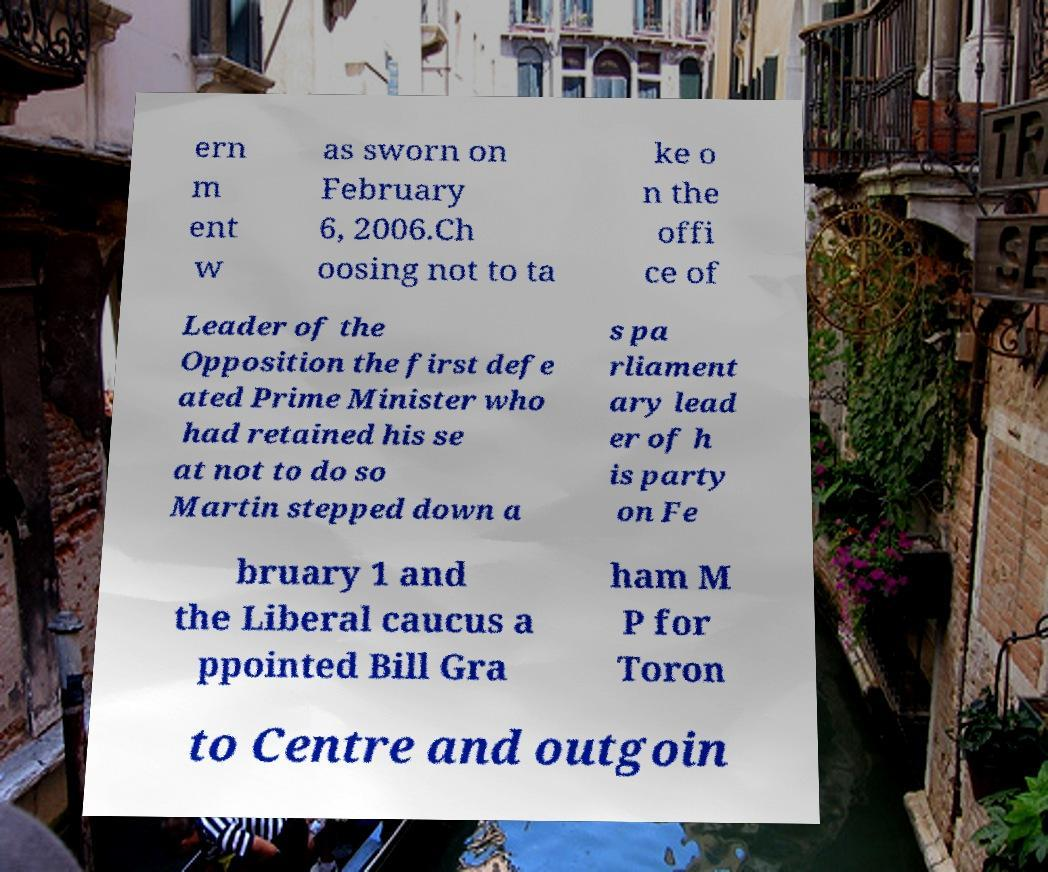There's text embedded in this image that I need extracted. Can you transcribe it verbatim? ern m ent w as sworn on February 6, 2006.Ch oosing not to ta ke o n the offi ce of Leader of the Opposition the first defe ated Prime Minister who had retained his se at not to do so Martin stepped down a s pa rliament ary lead er of h is party on Fe bruary 1 and the Liberal caucus a ppointed Bill Gra ham M P for Toron to Centre and outgoin 